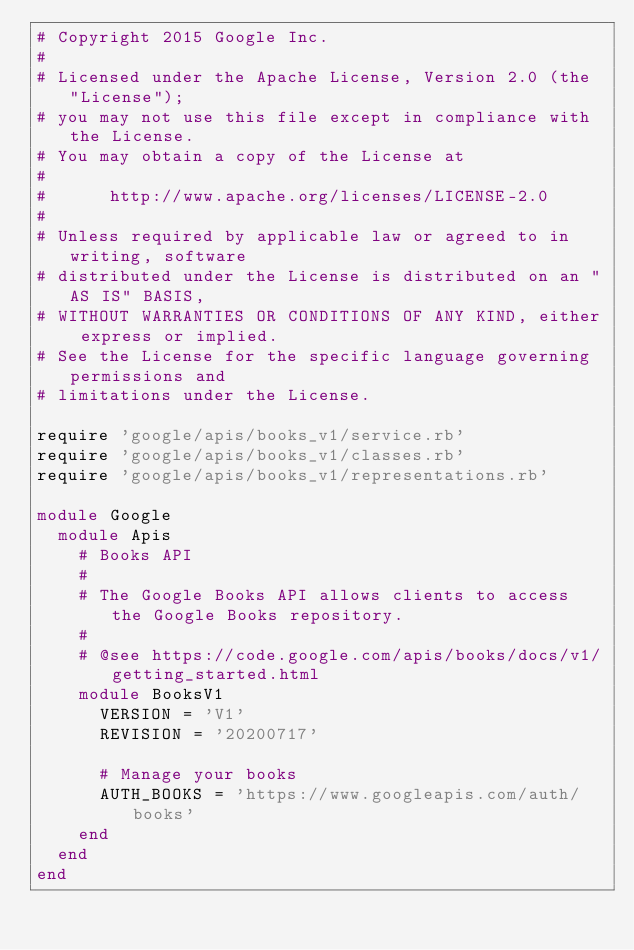<code> <loc_0><loc_0><loc_500><loc_500><_Ruby_># Copyright 2015 Google Inc.
#
# Licensed under the Apache License, Version 2.0 (the "License");
# you may not use this file except in compliance with the License.
# You may obtain a copy of the License at
#
#      http://www.apache.org/licenses/LICENSE-2.0
#
# Unless required by applicable law or agreed to in writing, software
# distributed under the License is distributed on an "AS IS" BASIS,
# WITHOUT WARRANTIES OR CONDITIONS OF ANY KIND, either express or implied.
# See the License for the specific language governing permissions and
# limitations under the License.

require 'google/apis/books_v1/service.rb'
require 'google/apis/books_v1/classes.rb'
require 'google/apis/books_v1/representations.rb'

module Google
  module Apis
    # Books API
    #
    # The Google Books API allows clients to access the Google Books repository.
    #
    # @see https://code.google.com/apis/books/docs/v1/getting_started.html
    module BooksV1
      VERSION = 'V1'
      REVISION = '20200717'

      # Manage your books
      AUTH_BOOKS = 'https://www.googleapis.com/auth/books'
    end
  end
end
</code> 